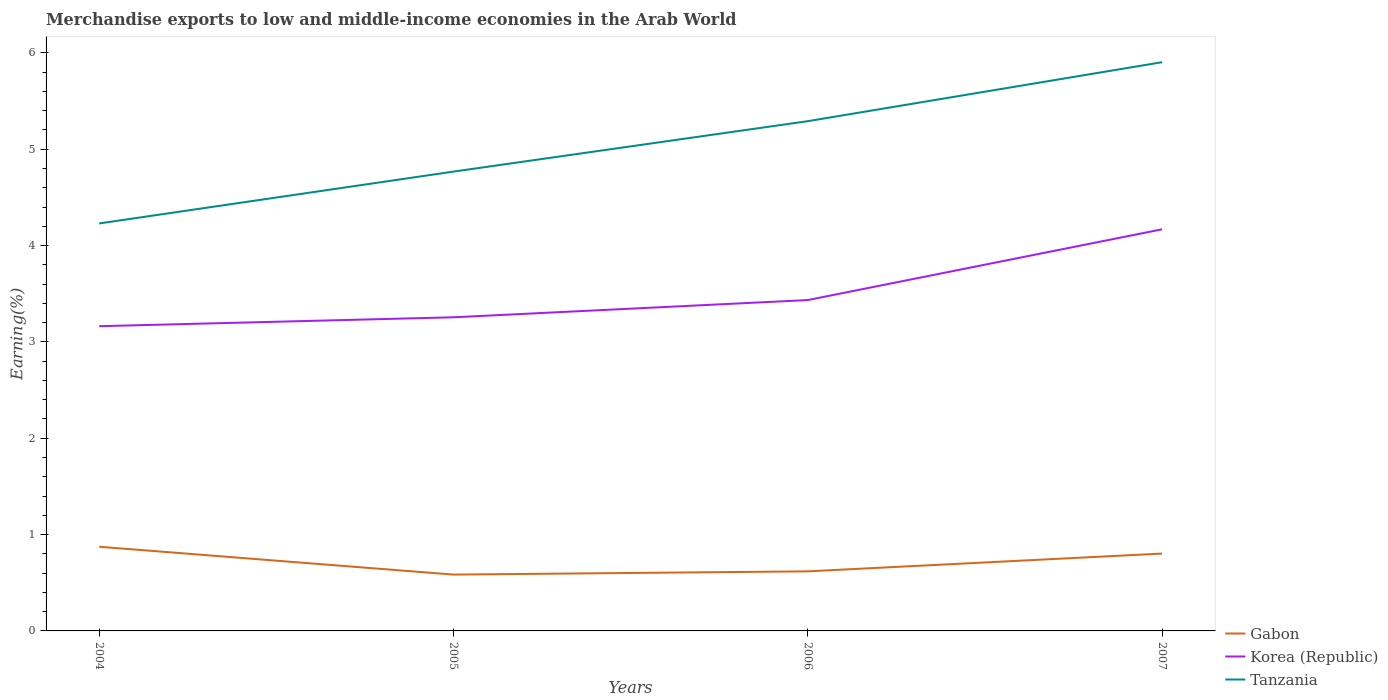How many different coloured lines are there?
Provide a succinct answer. 3. Does the line corresponding to Korea (Republic) intersect with the line corresponding to Tanzania?
Offer a terse response. No. Across all years, what is the maximum percentage of amount earned from merchandise exports in Korea (Republic)?
Give a very brief answer. 3.16. What is the total percentage of amount earned from merchandise exports in Gabon in the graph?
Keep it short and to the point. 0.07. What is the difference between the highest and the second highest percentage of amount earned from merchandise exports in Korea (Republic)?
Provide a short and direct response. 1.01. What is the difference between the highest and the lowest percentage of amount earned from merchandise exports in Gabon?
Your response must be concise. 2. How many years are there in the graph?
Your answer should be compact. 4. Does the graph contain any zero values?
Keep it short and to the point. No. Does the graph contain grids?
Make the answer very short. No. Where does the legend appear in the graph?
Make the answer very short. Bottom right. What is the title of the graph?
Ensure brevity in your answer.  Merchandise exports to low and middle-income economies in the Arab World. What is the label or title of the X-axis?
Ensure brevity in your answer.  Years. What is the label or title of the Y-axis?
Ensure brevity in your answer.  Earning(%). What is the Earning(%) of Gabon in 2004?
Offer a very short reply. 0.87. What is the Earning(%) of Korea (Republic) in 2004?
Offer a very short reply. 3.16. What is the Earning(%) of Tanzania in 2004?
Provide a succinct answer. 4.23. What is the Earning(%) in Gabon in 2005?
Ensure brevity in your answer.  0.58. What is the Earning(%) of Korea (Republic) in 2005?
Provide a short and direct response. 3.26. What is the Earning(%) in Tanzania in 2005?
Your response must be concise. 4.77. What is the Earning(%) in Gabon in 2006?
Keep it short and to the point. 0.62. What is the Earning(%) of Korea (Republic) in 2006?
Offer a very short reply. 3.43. What is the Earning(%) in Tanzania in 2006?
Make the answer very short. 5.29. What is the Earning(%) of Gabon in 2007?
Your answer should be very brief. 0.8. What is the Earning(%) in Korea (Republic) in 2007?
Provide a short and direct response. 4.17. What is the Earning(%) in Tanzania in 2007?
Provide a succinct answer. 5.9. Across all years, what is the maximum Earning(%) in Gabon?
Offer a very short reply. 0.87. Across all years, what is the maximum Earning(%) in Korea (Republic)?
Give a very brief answer. 4.17. Across all years, what is the maximum Earning(%) in Tanzania?
Offer a very short reply. 5.9. Across all years, what is the minimum Earning(%) in Gabon?
Ensure brevity in your answer.  0.58. Across all years, what is the minimum Earning(%) in Korea (Republic)?
Ensure brevity in your answer.  3.16. Across all years, what is the minimum Earning(%) in Tanzania?
Offer a very short reply. 4.23. What is the total Earning(%) of Gabon in the graph?
Offer a very short reply. 2.88. What is the total Earning(%) of Korea (Republic) in the graph?
Give a very brief answer. 14.02. What is the total Earning(%) in Tanzania in the graph?
Give a very brief answer. 20.19. What is the difference between the Earning(%) in Gabon in 2004 and that in 2005?
Your answer should be very brief. 0.29. What is the difference between the Earning(%) in Korea (Republic) in 2004 and that in 2005?
Your answer should be compact. -0.09. What is the difference between the Earning(%) in Tanzania in 2004 and that in 2005?
Make the answer very short. -0.54. What is the difference between the Earning(%) of Gabon in 2004 and that in 2006?
Give a very brief answer. 0.26. What is the difference between the Earning(%) of Korea (Republic) in 2004 and that in 2006?
Offer a terse response. -0.27. What is the difference between the Earning(%) of Tanzania in 2004 and that in 2006?
Provide a succinct answer. -1.06. What is the difference between the Earning(%) in Gabon in 2004 and that in 2007?
Offer a terse response. 0.07. What is the difference between the Earning(%) in Korea (Republic) in 2004 and that in 2007?
Ensure brevity in your answer.  -1.01. What is the difference between the Earning(%) in Tanzania in 2004 and that in 2007?
Provide a short and direct response. -1.67. What is the difference between the Earning(%) of Gabon in 2005 and that in 2006?
Offer a very short reply. -0.03. What is the difference between the Earning(%) of Korea (Republic) in 2005 and that in 2006?
Give a very brief answer. -0.18. What is the difference between the Earning(%) in Tanzania in 2005 and that in 2006?
Offer a terse response. -0.52. What is the difference between the Earning(%) of Gabon in 2005 and that in 2007?
Provide a short and direct response. -0.22. What is the difference between the Earning(%) in Korea (Republic) in 2005 and that in 2007?
Your answer should be compact. -0.91. What is the difference between the Earning(%) of Tanzania in 2005 and that in 2007?
Offer a very short reply. -1.14. What is the difference between the Earning(%) of Gabon in 2006 and that in 2007?
Provide a succinct answer. -0.18. What is the difference between the Earning(%) in Korea (Republic) in 2006 and that in 2007?
Your answer should be very brief. -0.73. What is the difference between the Earning(%) in Tanzania in 2006 and that in 2007?
Your response must be concise. -0.61. What is the difference between the Earning(%) in Gabon in 2004 and the Earning(%) in Korea (Republic) in 2005?
Offer a terse response. -2.38. What is the difference between the Earning(%) in Gabon in 2004 and the Earning(%) in Tanzania in 2005?
Give a very brief answer. -3.89. What is the difference between the Earning(%) in Korea (Republic) in 2004 and the Earning(%) in Tanzania in 2005?
Your answer should be very brief. -1.6. What is the difference between the Earning(%) in Gabon in 2004 and the Earning(%) in Korea (Republic) in 2006?
Ensure brevity in your answer.  -2.56. What is the difference between the Earning(%) in Gabon in 2004 and the Earning(%) in Tanzania in 2006?
Keep it short and to the point. -4.42. What is the difference between the Earning(%) of Korea (Republic) in 2004 and the Earning(%) of Tanzania in 2006?
Your answer should be compact. -2.13. What is the difference between the Earning(%) in Gabon in 2004 and the Earning(%) in Korea (Republic) in 2007?
Make the answer very short. -3.29. What is the difference between the Earning(%) in Gabon in 2004 and the Earning(%) in Tanzania in 2007?
Your response must be concise. -5.03. What is the difference between the Earning(%) of Korea (Republic) in 2004 and the Earning(%) of Tanzania in 2007?
Your response must be concise. -2.74. What is the difference between the Earning(%) of Gabon in 2005 and the Earning(%) of Korea (Republic) in 2006?
Offer a terse response. -2.85. What is the difference between the Earning(%) of Gabon in 2005 and the Earning(%) of Tanzania in 2006?
Provide a short and direct response. -4.71. What is the difference between the Earning(%) of Korea (Republic) in 2005 and the Earning(%) of Tanzania in 2006?
Your response must be concise. -2.04. What is the difference between the Earning(%) of Gabon in 2005 and the Earning(%) of Korea (Republic) in 2007?
Provide a short and direct response. -3.58. What is the difference between the Earning(%) in Gabon in 2005 and the Earning(%) in Tanzania in 2007?
Offer a very short reply. -5.32. What is the difference between the Earning(%) of Korea (Republic) in 2005 and the Earning(%) of Tanzania in 2007?
Provide a succinct answer. -2.65. What is the difference between the Earning(%) of Gabon in 2006 and the Earning(%) of Korea (Republic) in 2007?
Your answer should be compact. -3.55. What is the difference between the Earning(%) of Gabon in 2006 and the Earning(%) of Tanzania in 2007?
Offer a very short reply. -5.28. What is the difference between the Earning(%) in Korea (Republic) in 2006 and the Earning(%) in Tanzania in 2007?
Give a very brief answer. -2.47. What is the average Earning(%) of Gabon per year?
Your response must be concise. 0.72. What is the average Earning(%) of Korea (Republic) per year?
Make the answer very short. 3.51. What is the average Earning(%) of Tanzania per year?
Provide a succinct answer. 5.05. In the year 2004, what is the difference between the Earning(%) in Gabon and Earning(%) in Korea (Republic)?
Offer a very short reply. -2.29. In the year 2004, what is the difference between the Earning(%) in Gabon and Earning(%) in Tanzania?
Give a very brief answer. -3.36. In the year 2004, what is the difference between the Earning(%) of Korea (Republic) and Earning(%) of Tanzania?
Provide a short and direct response. -1.07. In the year 2005, what is the difference between the Earning(%) of Gabon and Earning(%) of Korea (Republic)?
Offer a terse response. -2.67. In the year 2005, what is the difference between the Earning(%) of Gabon and Earning(%) of Tanzania?
Provide a succinct answer. -4.18. In the year 2005, what is the difference between the Earning(%) of Korea (Republic) and Earning(%) of Tanzania?
Your answer should be compact. -1.51. In the year 2006, what is the difference between the Earning(%) of Gabon and Earning(%) of Korea (Republic)?
Provide a succinct answer. -2.82. In the year 2006, what is the difference between the Earning(%) in Gabon and Earning(%) in Tanzania?
Your response must be concise. -4.67. In the year 2006, what is the difference between the Earning(%) of Korea (Republic) and Earning(%) of Tanzania?
Keep it short and to the point. -1.86. In the year 2007, what is the difference between the Earning(%) of Gabon and Earning(%) of Korea (Republic)?
Give a very brief answer. -3.37. In the year 2007, what is the difference between the Earning(%) of Gabon and Earning(%) of Tanzania?
Give a very brief answer. -5.1. In the year 2007, what is the difference between the Earning(%) in Korea (Republic) and Earning(%) in Tanzania?
Keep it short and to the point. -1.73. What is the ratio of the Earning(%) of Gabon in 2004 to that in 2005?
Make the answer very short. 1.49. What is the ratio of the Earning(%) in Korea (Republic) in 2004 to that in 2005?
Keep it short and to the point. 0.97. What is the ratio of the Earning(%) in Tanzania in 2004 to that in 2005?
Your response must be concise. 0.89. What is the ratio of the Earning(%) in Gabon in 2004 to that in 2006?
Offer a very short reply. 1.41. What is the ratio of the Earning(%) in Korea (Republic) in 2004 to that in 2006?
Give a very brief answer. 0.92. What is the ratio of the Earning(%) of Tanzania in 2004 to that in 2006?
Provide a short and direct response. 0.8. What is the ratio of the Earning(%) in Gabon in 2004 to that in 2007?
Give a very brief answer. 1.09. What is the ratio of the Earning(%) of Korea (Republic) in 2004 to that in 2007?
Your response must be concise. 0.76. What is the ratio of the Earning(%) of Tanzania in 2004 to that in 2007?
Make the answer very short. 0.72. What is the ratio of the Earning(%) of Gabon in 2005 to that in 2006?
Ensure brevity in your answer.  0.95. What is the ratio of the Earning(%) of Korea (Republic) in 2005 to that in 2006?
Keep it short and to the point. 0.95. What is the ratio of the Earning(%) in Tanzania in 2005 to that in 2006?
Provide a succinct answer. 0.9. What is the ratio of the Earning(%) of Gabon in 2005 to that in 2007?
Offer a terse response. 0.73. What is the ratio of the Earning(%) of Korea (Republic) in 2005 to that in 2007?
Give a very brief answer. 0.78. What is the ratio of the Earning(%) in Tanzania in 2005 to that in 2007?
Give a very brief answer. 0.81. What is the ratio of the Earning(%) in Gabon in 2006 to that in 2007?
Offer a very short reply. 0.77. What is the ratio of the Earning(%) of Korea (Republic) in 2006 to that in 2007?
Provide a short and direct response. 0.82. What is the ratio of the Earning(%) in Tanzania in 2006 to that in 2007?
Provide a succinct answer. 0.9. What is the difference between the highest and the second highest Earning(%) in Gabon?
Your answer should be very brief. 0.07. What is the difference between the highest and the second highest Earning(%) of Korea (Republic)?
Offer a terse response. 0.73. What is the difference between the highest and the second highest Earning(%) of Tanzania?
Offer a very short reply. 0.61. What is the difference between the highest and the lowest Earning(%) in Gabon?
Your response must be concise. 0.29. What is the difference between the highest and the lowest Earning(%) in Korea (Republic)?
Provide a short and direct response. 1.01. What is the difference between the highest and the lowest Earning(%) in Tanzania?
Offer a very short reply. 1.67. 